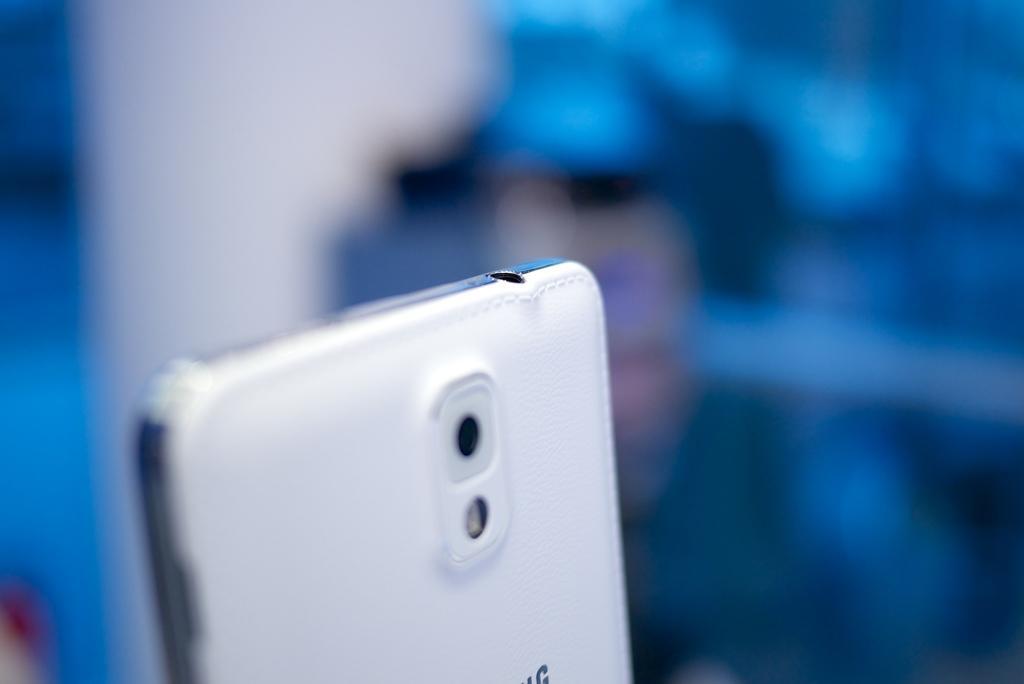Describe this image in one or two sentences. In this picture I can see a mobile, and there is blur background. 